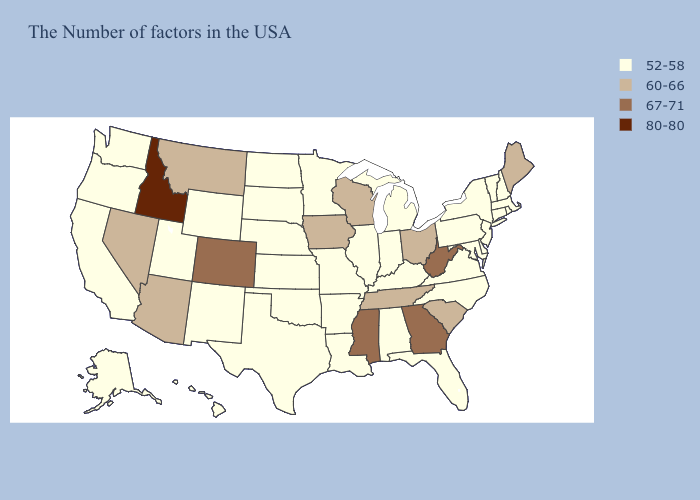Among the states that border Missouri , does Tennessee have the lowest value?
Concise answer only. No. What is the highest value in the USA?
Answer briefly. 80-80. What is the value of California?
Give a very brief answer. 52-58. Among the states that border Kansas , does Colorado have the highest value?
Keep it brief. Yes. Does the first symbol in the legend represent the smallest category?
Write a very short answer. Yes. Among the states that border Utah , which have the highest value?
Write a very short answer. Idaho. Name the states that have a value in the range 52-58?
Be succinct. Massachusetts, Rhode Island, New Hampshire, Vermont, Connecticut, New York, New Jersey, Delaware, Maryland, Pennsylvania, Virginia, North Carolina, Florida, Michigan, Kentucky, Indiana, Alabama, Illinois, Louisiana, Missouri, Arkansas, Minnesota, Kansas, Nebraska, Oklahoma, Texas, South Dakota, North Dakota, Wyoming, New Mexico, Utah, California, Washington, Oregon, Alaska, Hawaii. Name the states that have a value in the range 67-71?
Keep it brief. West Virginia, Georgia, Mississippi, Colorado. What is the highest value in the MidWest ?
Write a very short answer. 60-66. Does Rhode Island have the lowest value in the Northeast?
Write a very short answer. Yes. What is the value of Ohio?
Write a very short answer. 60-66. Does Missouri have the lowest value in the MidWest?
Answer briefly. Yes. What is the value of Montana?
Answer briefly. 60-66. What is the value of Washington?
Write a very short answer. 52-58. What is the value of Montana?
Give a very brief answer. 60-66. 